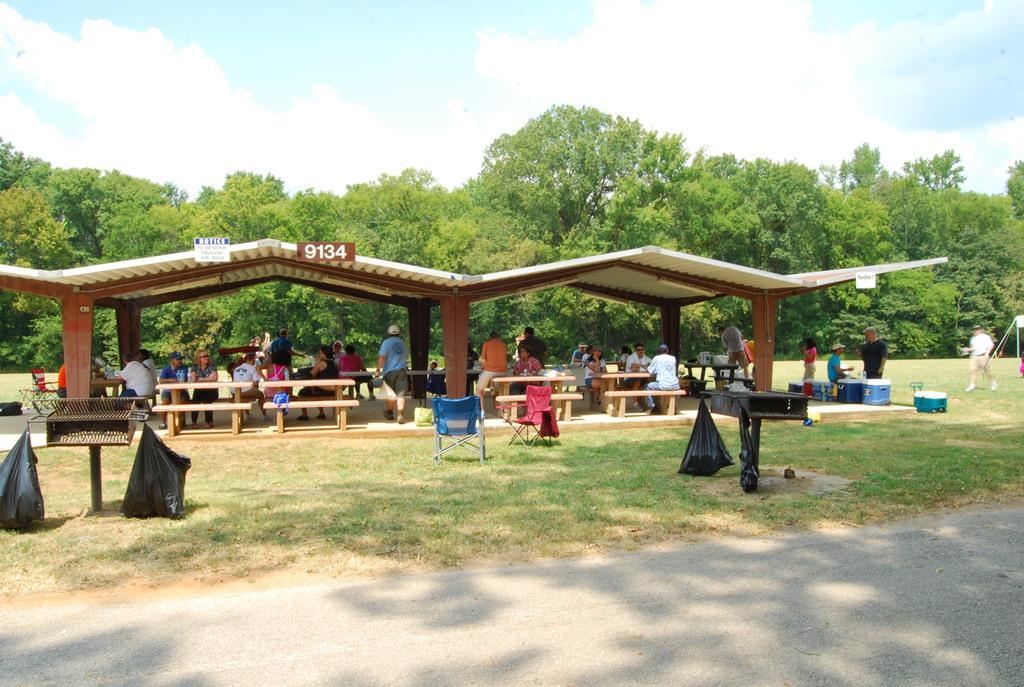Please provide a concise description of this image. In this image we can see a shed with pillars. There are benches and tables. There are many people. Some are sitting. Some are standing. Also there are stands. On the stands there are covers hanged. And there are chairs. On the ground there is grass. There is road. In the background there are trees. And there is sky with clouds. 